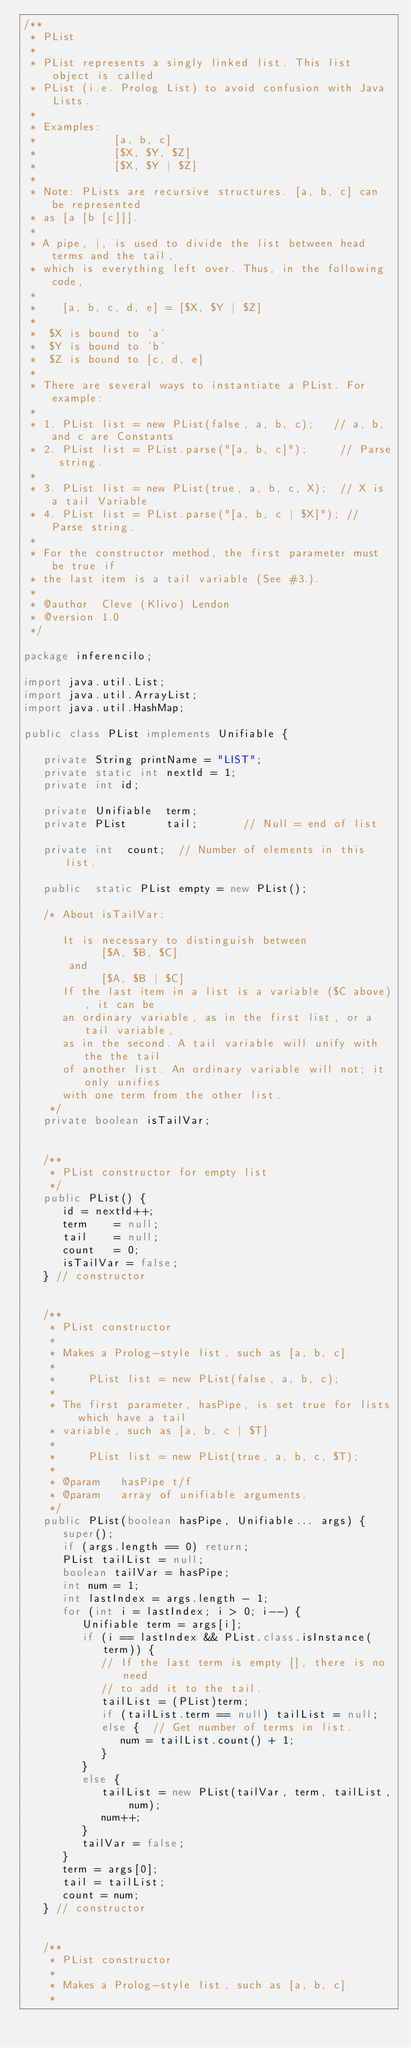<code> <loc_0><loc_0><loc_500><loc_500><_Java_>/**
 * PList
 *
 * PList represents a singly linked list. This list object is called
 * PList (i.e. Prolog List) to avoid confusion with Java Lists.
 *
 * Examples:
 *            [a, b, c]
 *            [$X, $Y, $Z]
 *            [$X, $Y | $Z]
 *
 * Note: PLists are recursive structures. [a, b, c] can be represented
 * as [a [b [c]]].
 *
 * A pipe, |, is used to divide the list between head terms and the tail,
 * which is everything left over. Thus, in the following code,
 *
 *    [a, b, c, d, e] = [$X, $Y | $Z]
 *
 *  $X is bound to 'a'
 *  $Y is bound to 'b'
 *  $Z is bound to [c, d, e]
 *
 * There are several ways to instantiate a PList. For example:
 *
 * 1. PList list = new PList(false, a, b, c);   // a, b, and c are Constants
 * 2. PList list = PList.parse("[a, b, c]");     // Parse string.
 *
 * 3. PList list = new PList(true, a, b, c, X);  // X is a tail Variable
 * 4. PList list = PList.parse("[a, b, c | $X]"); // Parse string.
 *
 * For the constructor method, the first parameter must be true if
 * the last item is a tail variable (See #3.).
 *
 * @author  Cleve (Klivo) Lendon
 * @version 1.0
 */

package inferencilo;

import java.util.List;
import java.util.ArrayList;
import java.util.HashMap;

public class PList implements Unifiable {

   private String printName = "LIST";
   private static int nextId = 1;
   private int id;

   private Unifiable  term;
   private PList      tail;       // Null = end of list

   private int  count;  // Number of elements in this list.

   public  static PList empty = new PList();

   /* About isTailVar:

      It is necessary to distinguish between
            [$A, $B, $C]
       and
            [$A, $B | $C]
      If the last item in a list is a variable ($C above), it can be
      an ordinary variable, as in the first list, or a tail variable,
      as in the second. A tail variable will unify with the the tail
      of another list. An ordinary variable will not; it only unifies
      with one term from the other list.
    */
   private boolean isTailVar;


   /**
    * PList constructor for empty list
    */
   public PList() {
      id = nextId++;
      term    = null;
      tail    = null;
      count   = 0;
      isTailVar = false;
   } // constructor


   /**
    * PList constructor
    *
    * Makes a Prolog-style list, such as [a, b, c]
    *
    *     PList list = new PList(false, a, b, c);
    *
    * The first parameter, hasPipe, is set true for lists which have a tail
    * variable, such as [a, b, c | $T]
    *
    *     PList list = new PList(true, a, b, c, $T);
    *
    * @param   hasPipe t/f
    * @param   array of unifiable arguments.
    */
   public PList(boolean hasPipe, Unifiable... args) {
      super();
      if (args.length == 0) return;
      PList tailList = null;
      boolean tailVar = hasPipe;
      int num = 1;
      int lastIndex = args.length - 1;
      for (int i = lastIndex; i > 0; i--) {
         Unifiable term = args[i];
         if (i == lastIndex && PList.class.isInstance(term)) {
            // If the last term is empty [], there is no need
            // to add it to the tail.
            tailList = (PList)term;
            if (tailList.term == null) tailList = null;
            else {  // Get number of terms in list.
               num = tailList.count() + 1;
            }
         }
         else {
            tailList = new PList(tailVar, term, tailList, num);
            num++;
         }
         tailVar = false;
      }
      term = args[0];
      tail = tailList;
      count = num;
   } // constructor


   /**
    * PList constructor
    *
    * Makes a Prolog-style list, such as [a, b, c]
    *</code> 